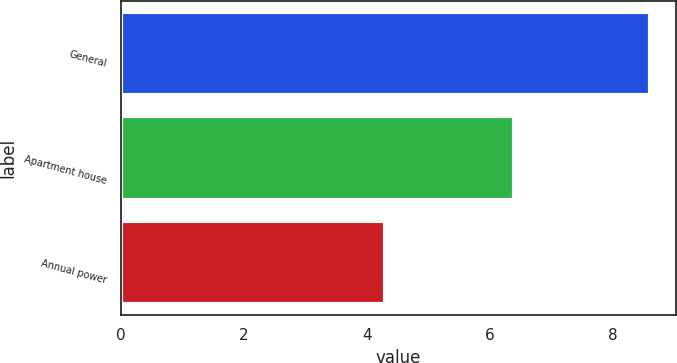Convert chart. <chart><loc_0><loc_0><loc_500><loc_500><bar_chart><fcel>General<fcel>Apartment house<fcel>Annual power<nl><fcel>8.6<fcel>6.4<fcel>4.3<nl></chart> 